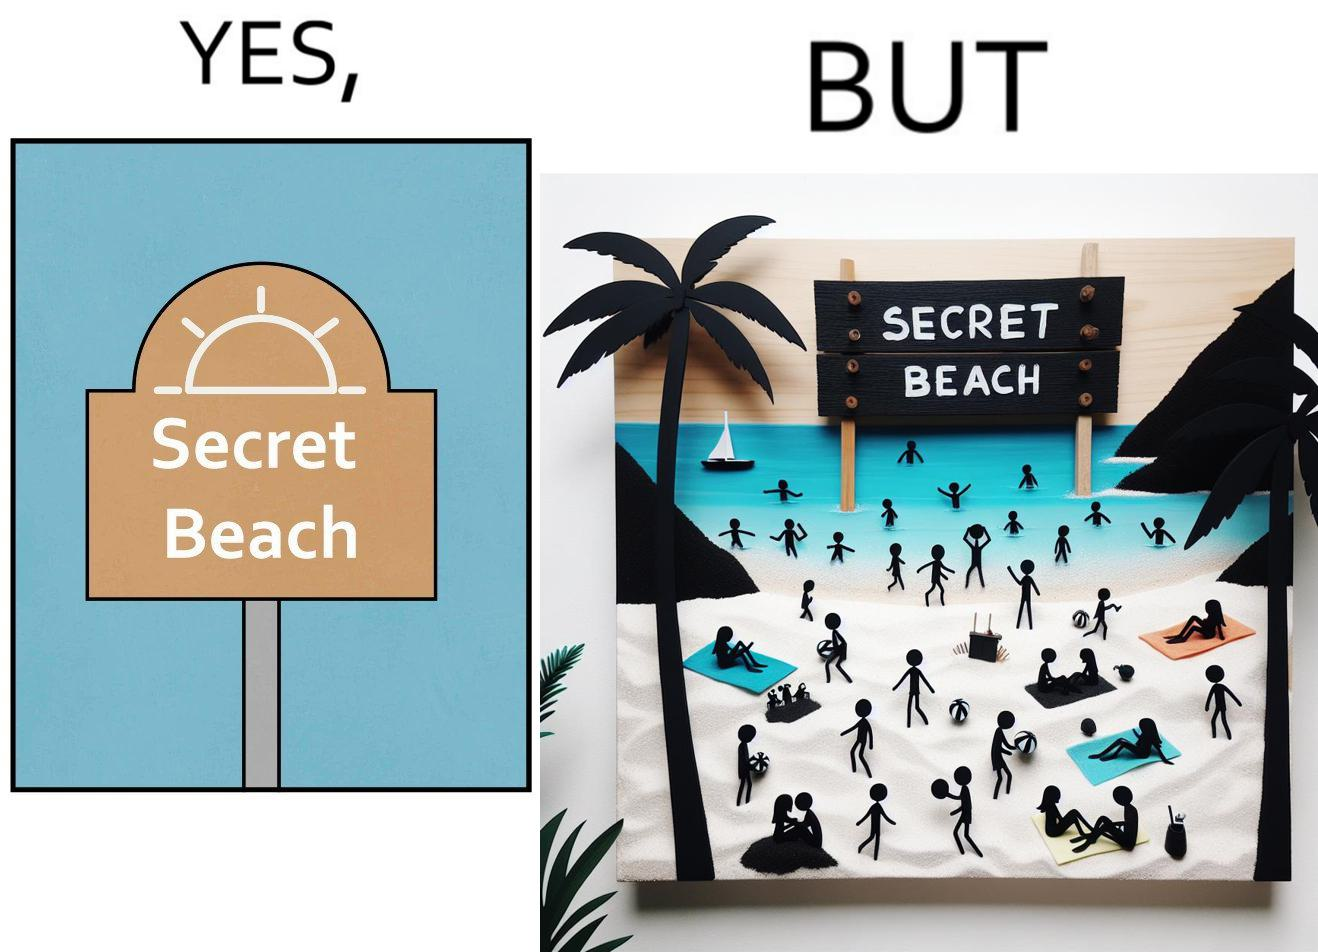Is this a satirical image? Yes, this image is satirical. 